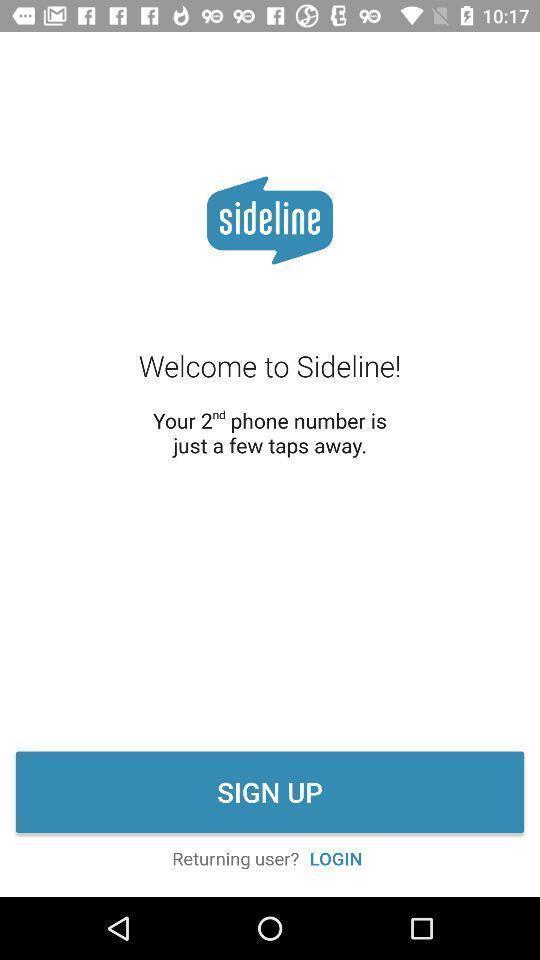Tell me what you see in this picture. Welcome page. 